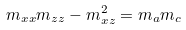<formula> <loc_0><loc_0><loc_500><loc_500>m _ { x x } m _ { z z } - m _ { x z } ^ { 2 } = m _ { a } m _ { c }</formula> 